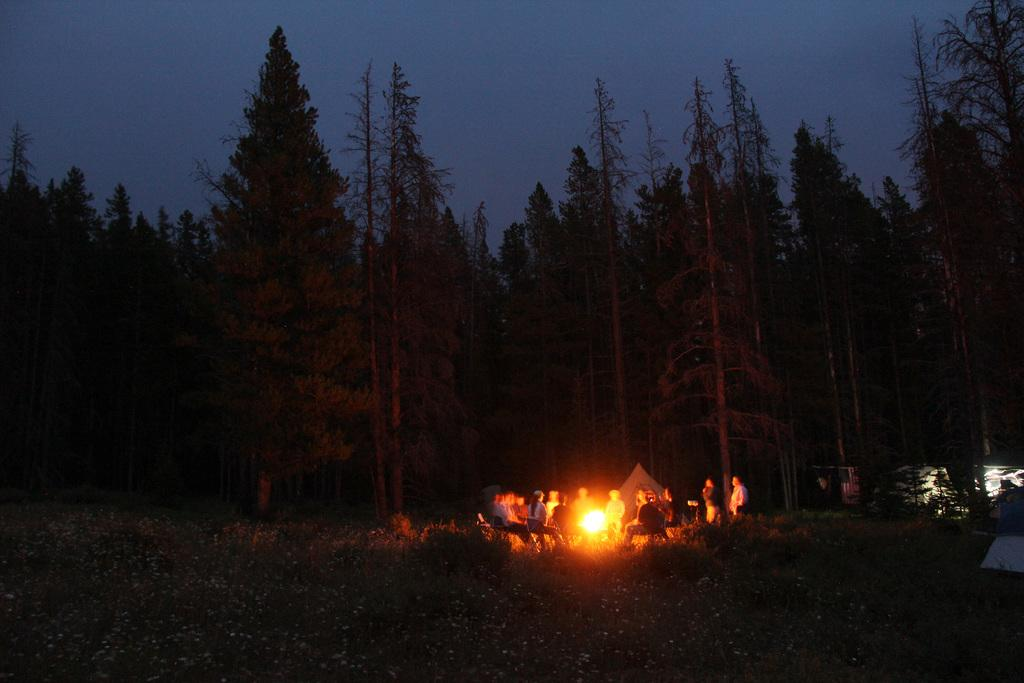How many people are in the image? There are people in the image, but the exact number is not specified. What is the main feature of the camping scene in the image? There is a campfire in the image. What type of shelter is present in the image? There are tents in the image. What mode of transportation can be seen in the image? There are vehicles in the image. What type of vegetation is present in the image? There are plants and trees in the image. What part of the natural environment is visible in the image? The sky is visible in the image. What type of station can be seen in the image? There is no station present in the image. What type of stone is being used to cook the meat in the image? There is no meat or stone present in the image. 